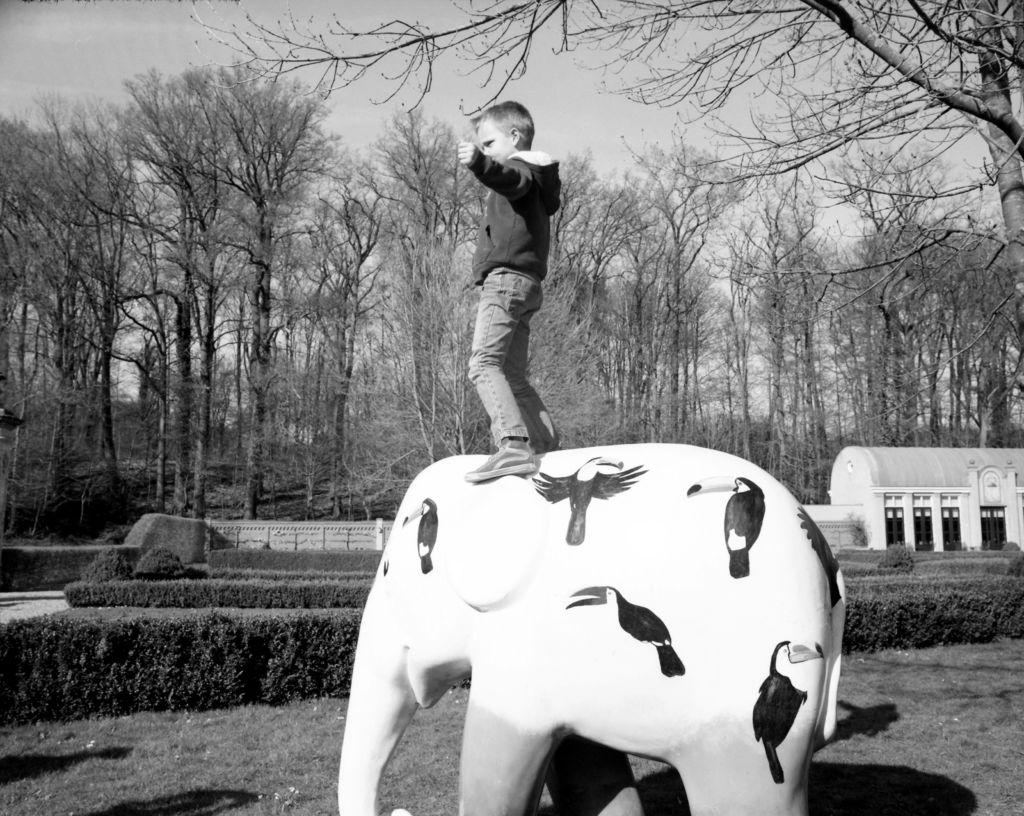Who is the main subject in the image? There is a boy in the image. What is the boy doing in the image? The boy is standing on a statue of an elephant. What can be seen in the background of the image? There is a building and trees in the background of the image. What is visible at the top of the image? The sky is visible at the top of the image. What type of ground is present at the bottom of the image? There is grass at the bottom of the image. What type of wrench is the boy using to fix the fan in the image? There is no wrench or fan present in the image; the boy is standing on a statue of an elephant. 